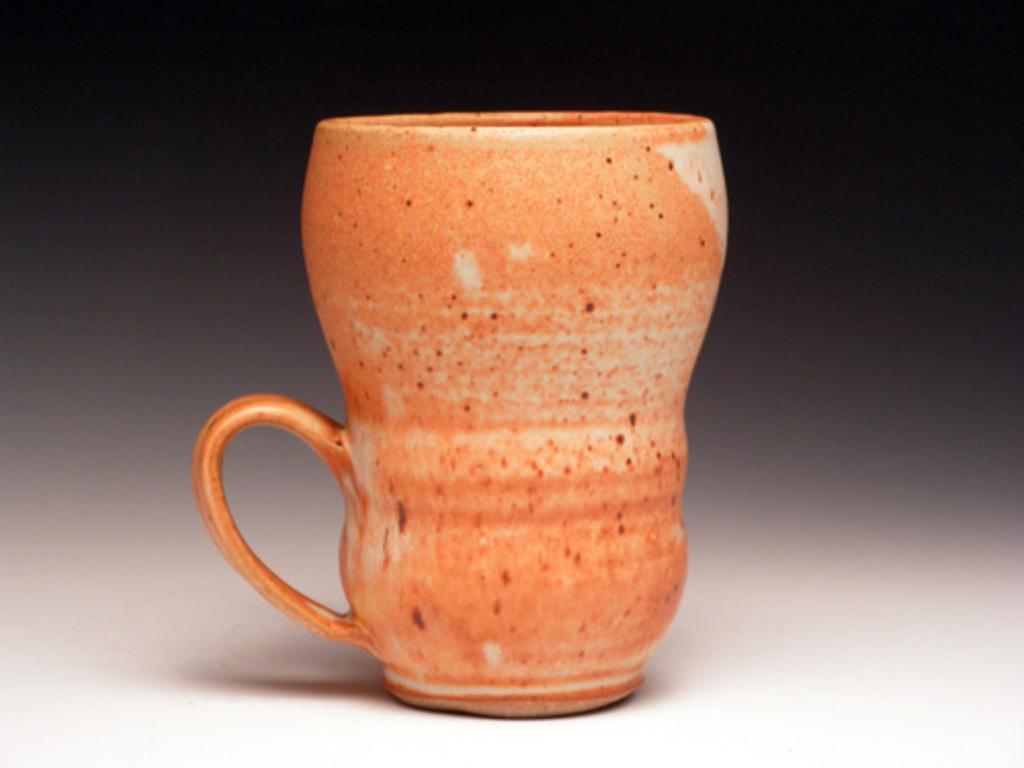In one or two sentences, can you explain what this image depicts? In this picture we can see a mug in the front, there is a blurry background. 